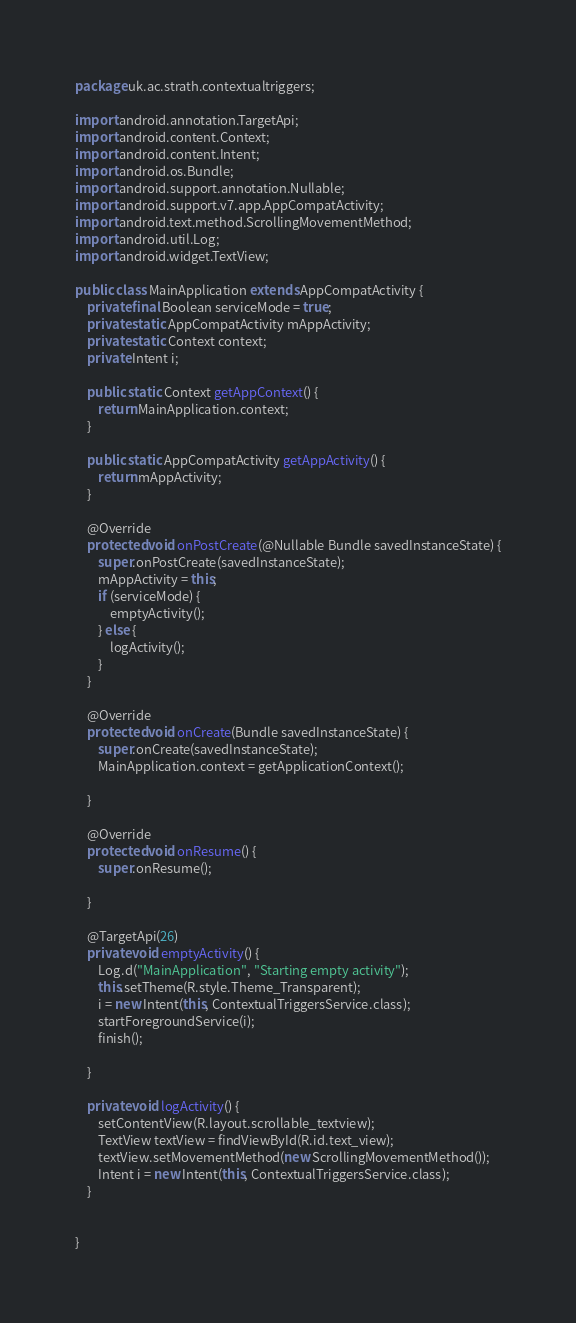<code> <loc_0><loc_0><loc_500><loc_500><_Java_>package uk.ac.strath.contextualtriggers;

import android.annotation.TargetApi;
import android.content.Context;
import android.content.Intent;
import android.os.Bundle;
import android.support.annotation.Nullable;
import android.support.v7.app.AppCompatActivity;
import android.text.method.ScrollingMovementMethod;
import android.util.Log;
import android.widget.TextView;

public class MainApplication extends AppCompatActivity {
    private final Boolean serviceMode = true;
    private static AppCompatActivity mAppActivity;
    private static Context context;
    private Intent i;

    public static Context getAppContext() {
        return MainApplication.context;
    }

    public static AppCompatActivity getAppActivity() {
        return mAppActivity;
    }

    @Override
    protected void onPostCreate(@Nullable Bundle savedInstanceState) {
        super.onPostCreate(savedInstanceState);
        mAppActivity = this;
        if (serviceMode) {
            emptyActivity();
        } else {
            logActivity();
        }
    }

    @Override
    protected void onCreate(Bundle savedInstanceState) {
        super.onCreate(savedInstanceState);
        MainApplication.context = getApplicationContext();

    }

    @Override
    protected void onResume() {
        super.onResume();

    }

    @TargetApi(26)
    private void emptyActivity() {
        Log.d("MainApplication", "Starting empty activity");
        this.setTheme(R.style.Theme_Transparent);
        i = new Intent(this, ContextualTriggersService.class);
        startForegroundService(i);
        finish();

    }

    private void logActivity() {
        setContentView(R.layout.scrollable_textview);
        TextView textView = findViewById(R.id.text_view);
        textView.setMovementMethod(new ScrollingMovementMethod());
        Intent i = new Intent(this, ContextualTriggersService.class);
    }


}
</code> 